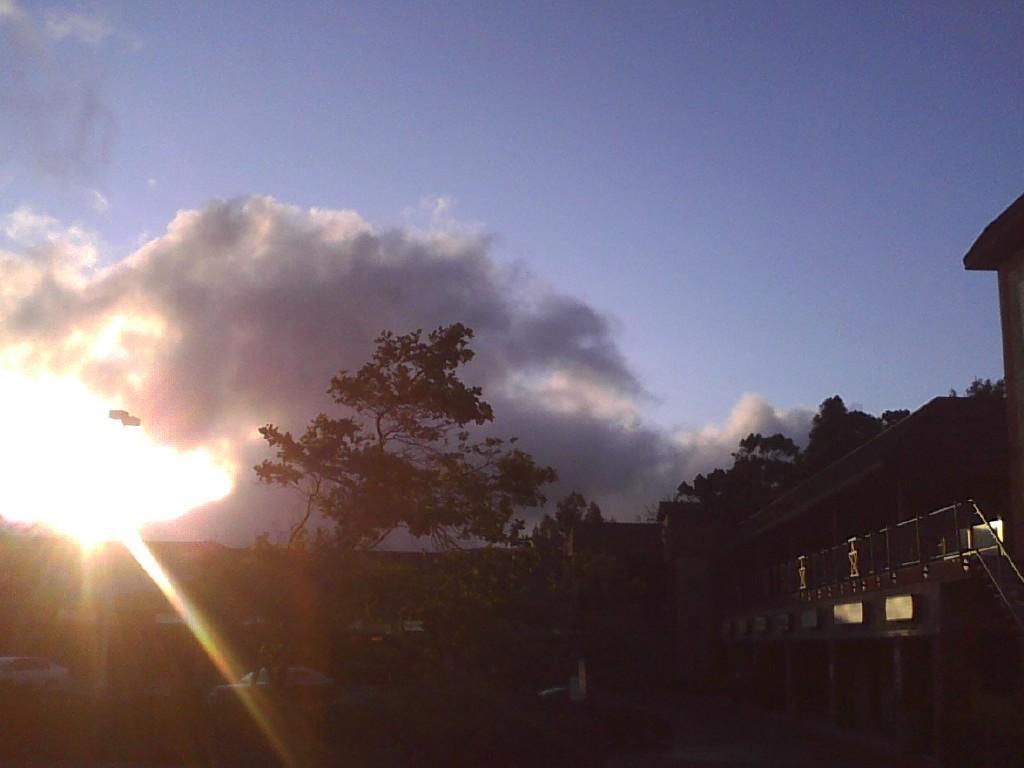Describe this image in one or two sentences. In the image we can see there are trees and there are buildings. There is sunlight in the sky and there is a cloudy sky. 